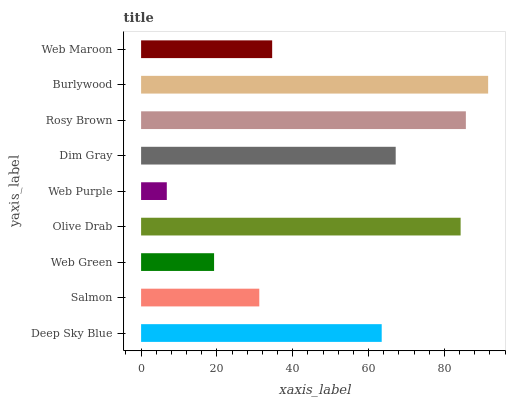Is Web Purple the minimum?
Answer yes or no. Yes. Is Burlywood the maximum?
Answer yes or no. Yes. Is Salmon the minimum?
Answer yes or no. No. Is Salmon the maximum?
Answer yes or no. No. Is Deep Sky Blue greater than Salmon?
Answer yes or no. Yes. Is Salmon less than Deep Sky Blue?
Answer yes or no. Yes. Is Salmon greater than Deep Sky Blue?
Answer yes or no. No. Is Deep Sky Blue less than Salmon?
Answer yes or no. No. Is Deep Sky Blue the high median?
Answer yes or no. Yes. Is Deep Sky Blue the low median?
Answer yes or no. Yes. Is Olive Drab the high median?
Answer yes or no. No. Is Salmon the low median?
Answer yes or no. No. 